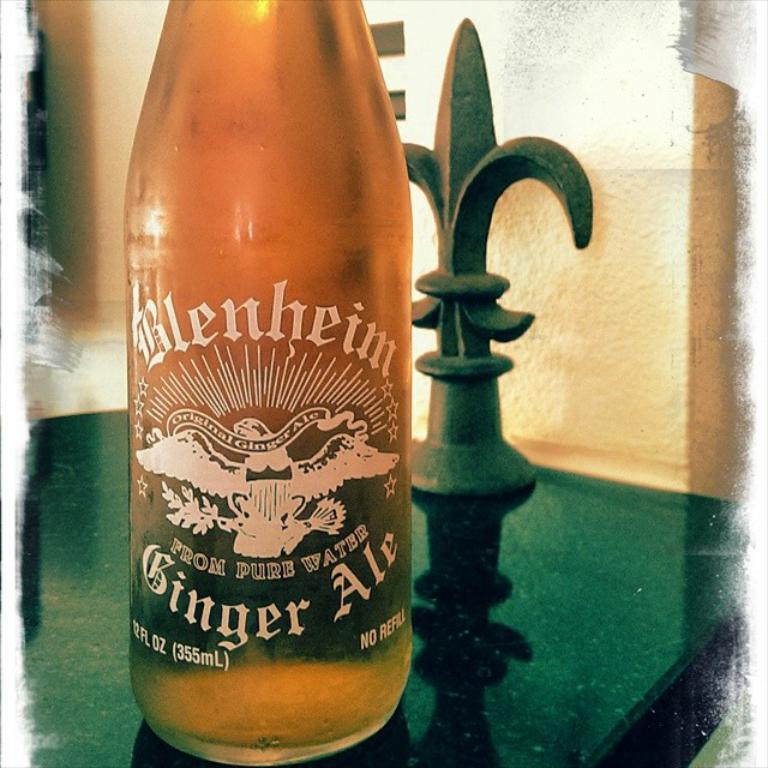<image>
Describe the image concisely. The single bottle shown contains ginger ale from Blenheim. 